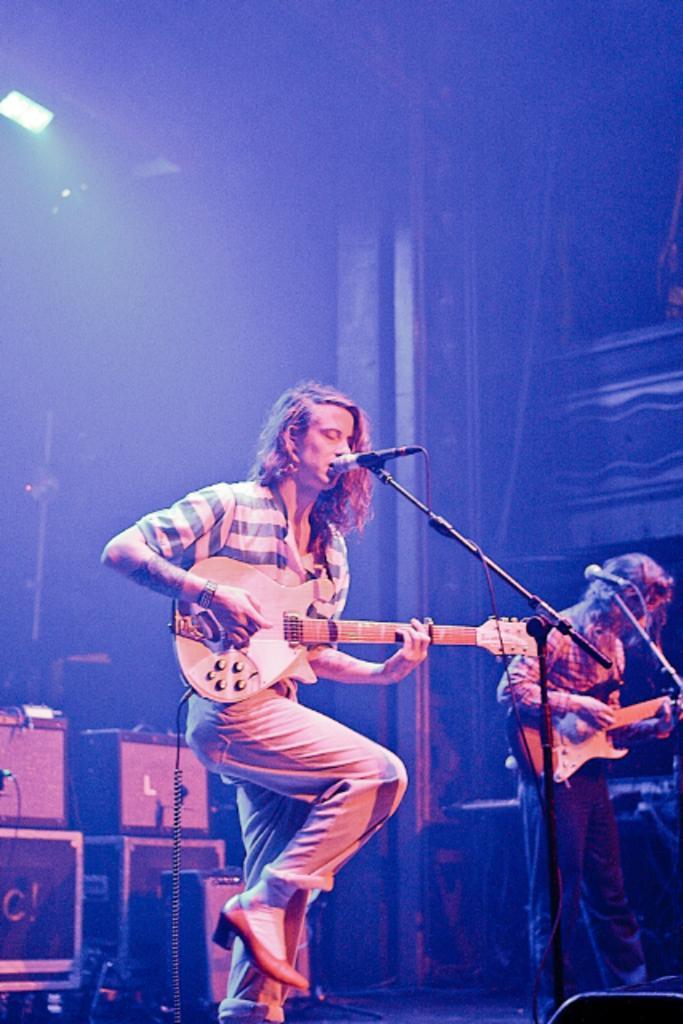In one or two sentences, can you explain what this image depicts? The photo is of a concert. In the center of the picture there is a man playing guitar and singing into a microphone. On the right there is another person standing playing guitar. On the right there is a microphone. On the left there are speaker and boxes. In the background there is a pillar frame and curtain. On the top left there is a focus light. 